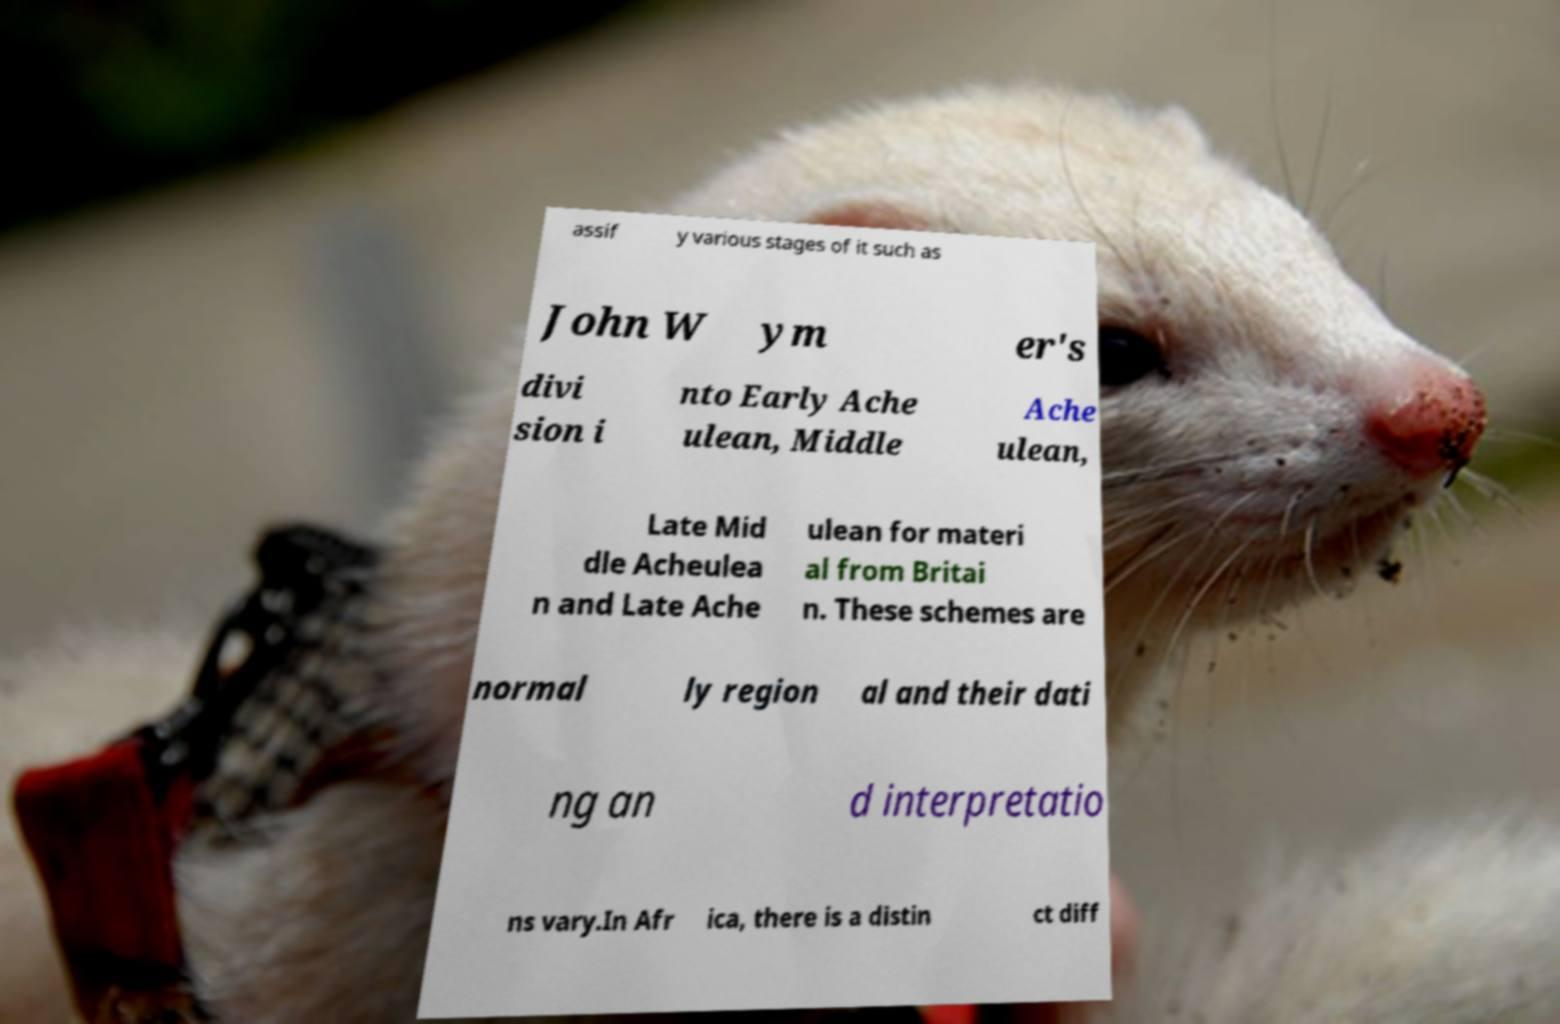Can you accurately transcribe the text from the provided image for me? assif y various stages of it such as John W ym er's divi sion i nto Early Ache ulean, Middle Ache ulean, Late Mid dle Acheulea n and Late Ache ulean for materi al from Britai n. These schemes are normal ly region al and their dati ng an d interpretatio ns vary.In Afr ica, there is a distin ct diff 